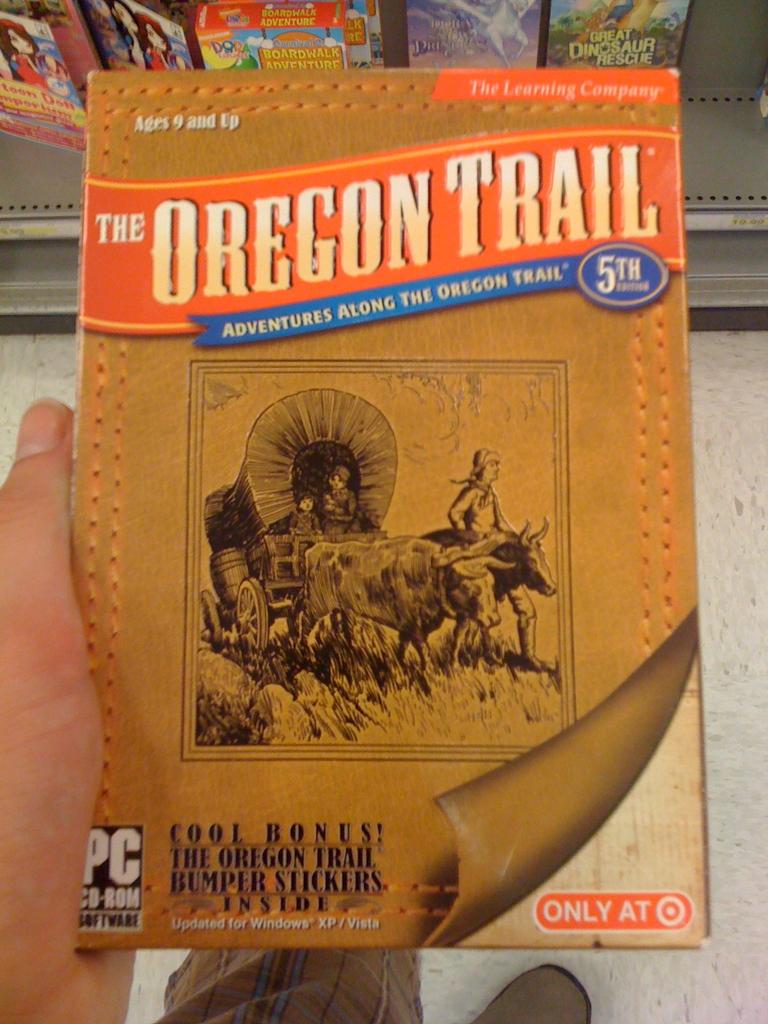What is included inside the book oregon trail?
Make the answer very short. Bumper stickers. For what age is this game for?
Make the answer very short. 9 and up. 